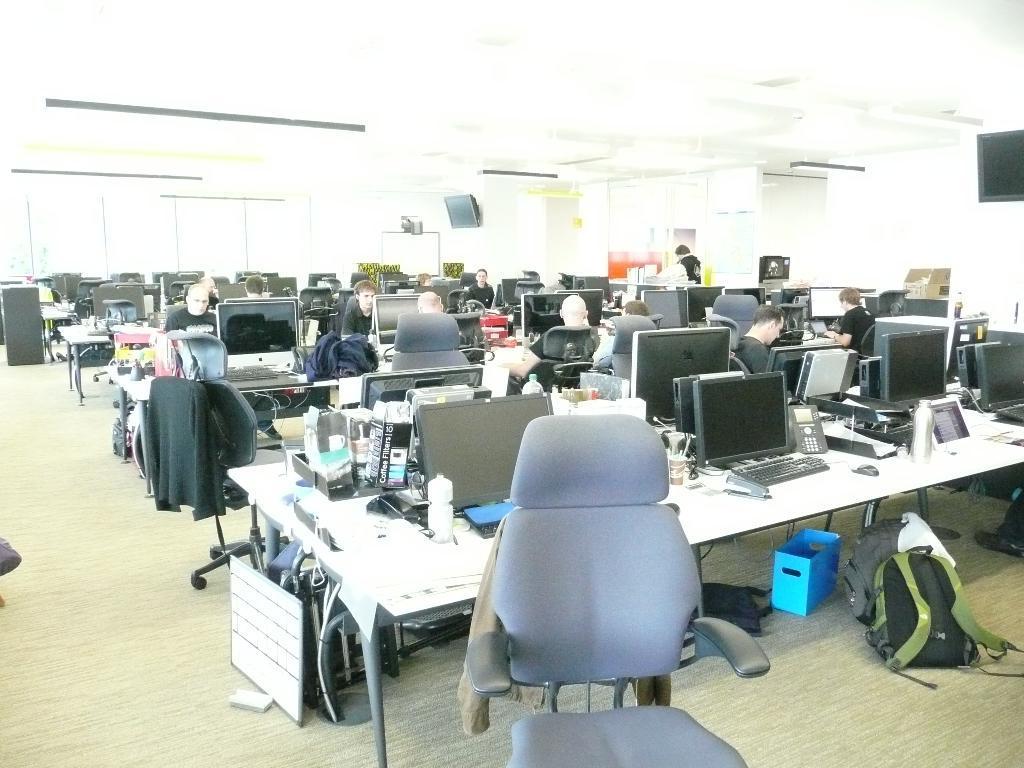Could you give a brief overview of what you see in this image? Here we can see a few electronic devices with keyboards which kept on this wooden table. We can see few people sitting on chair and working on a computer. These are the bags which are on the right side. 